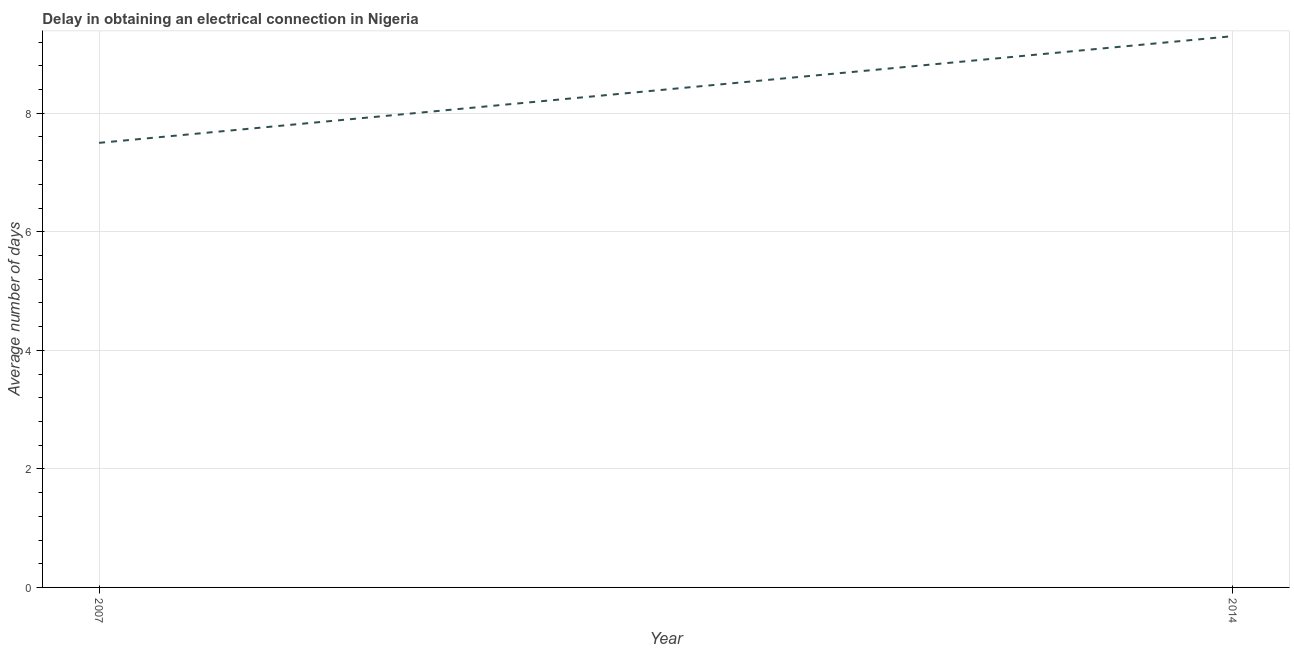Across all years, what is the minimum dalay in electrical connection?
Offer a terse response. 7.5. What is the difference between the dalay in electrical connection in 2007 and 2014?
Offer a terse response. -1.8. What is the average dalay in electrical connection per year?
Keep it short and to the point. 8.4. What is the ratio of the dalay in electrical connection in 2007 to that in 2014?
Make the answer very short. 0.81. In how many years, is the dalay in electrical connection greater than the average dalay in electrical connection taken over all years?
Give a very brief answer. 1. What is the difference between two consecutive major ticks on the Y-axis?
Provide a short and direct response. 2. Are the values on the major ticks of Y-axis written in scientific E-notation?
Offer a very short reply. No. Does the graph contain grids?
Offer a very short reply. Yes. What is the title of the graph?
Give a very brief answer. Delay in obtaining an electrical connection in Nigeria. What is the label or title of the Y-axis?
Provide a succinct answer. Average number of days. What is the Average number of days of 2007?
Your answer should be compact. 7.5. What is the difference between the Average number of days in 2007 and 2014?
Your answer should be compact. -1.8. What is the ratio of the Average number of days in 2007 to that in 2014?
Offer a very short reply. 0.81. 